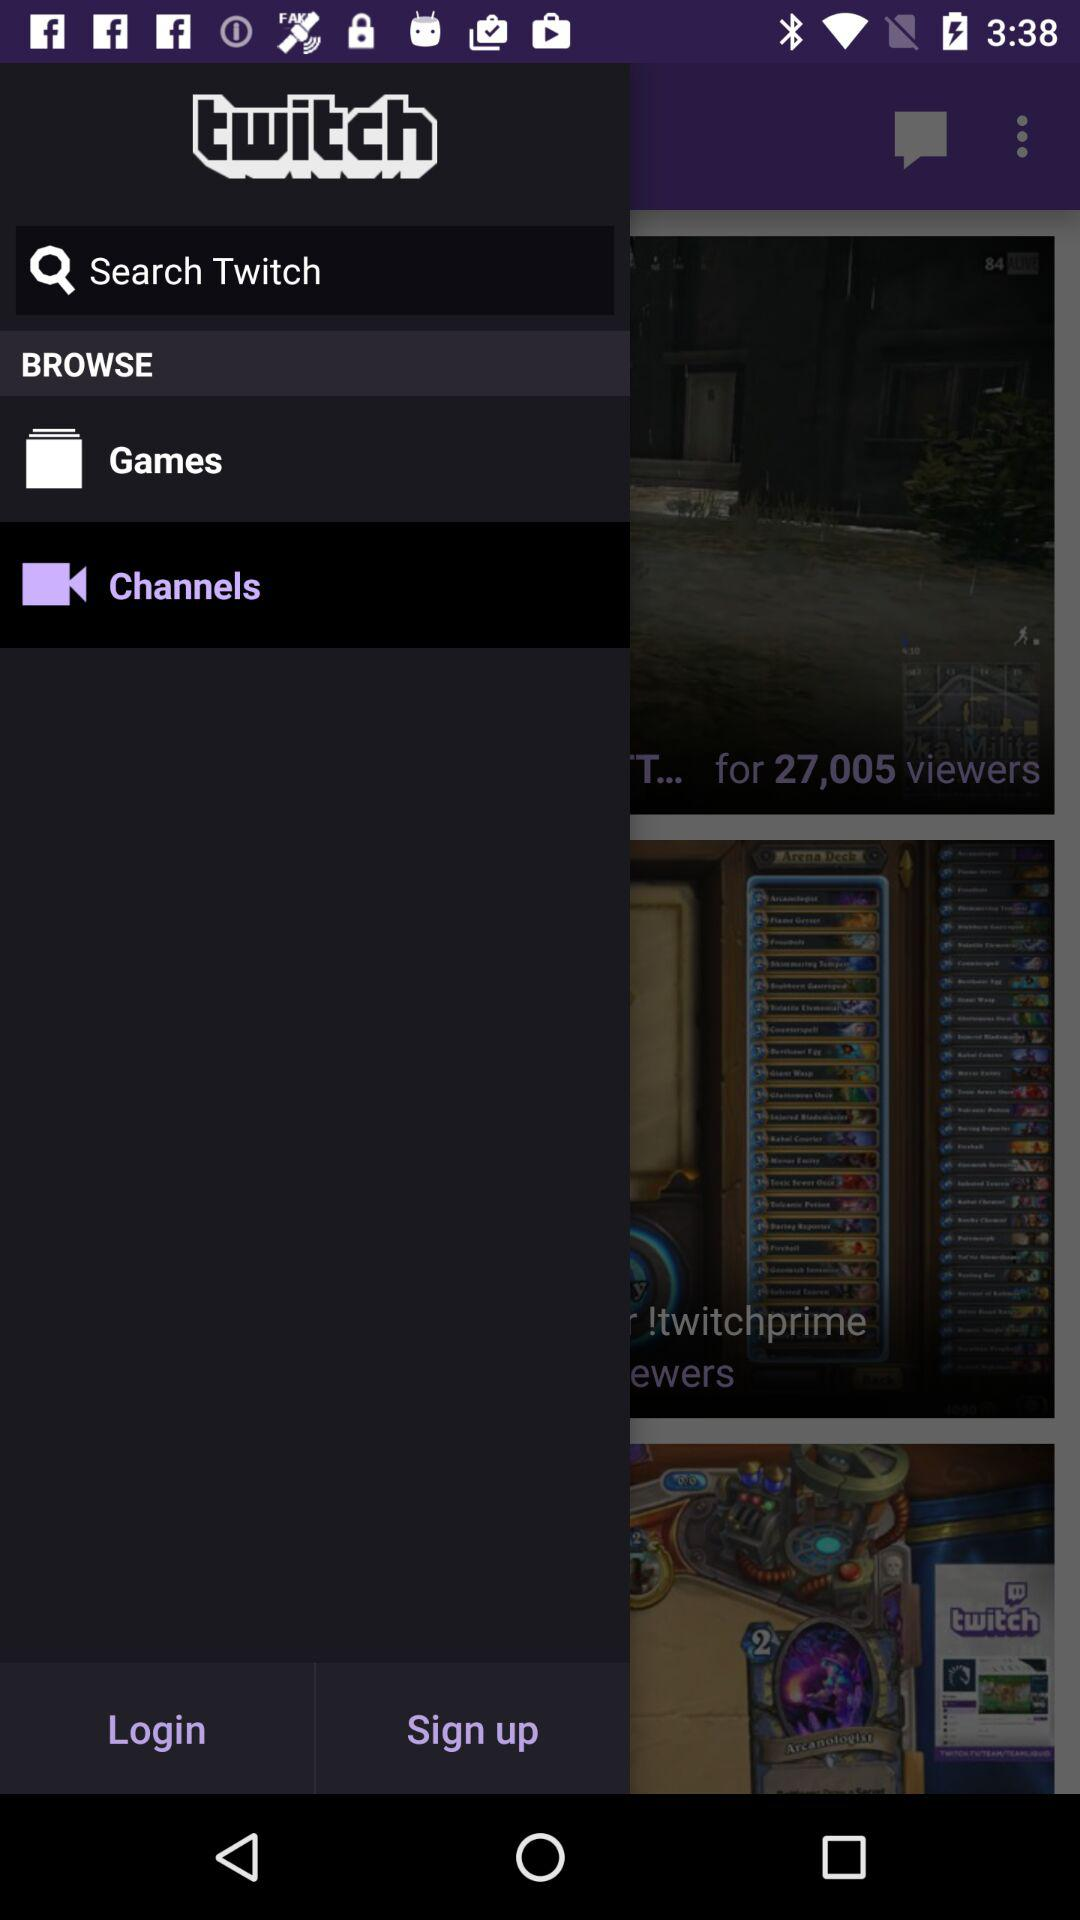What is the name of the application? The application name is "twitch". 